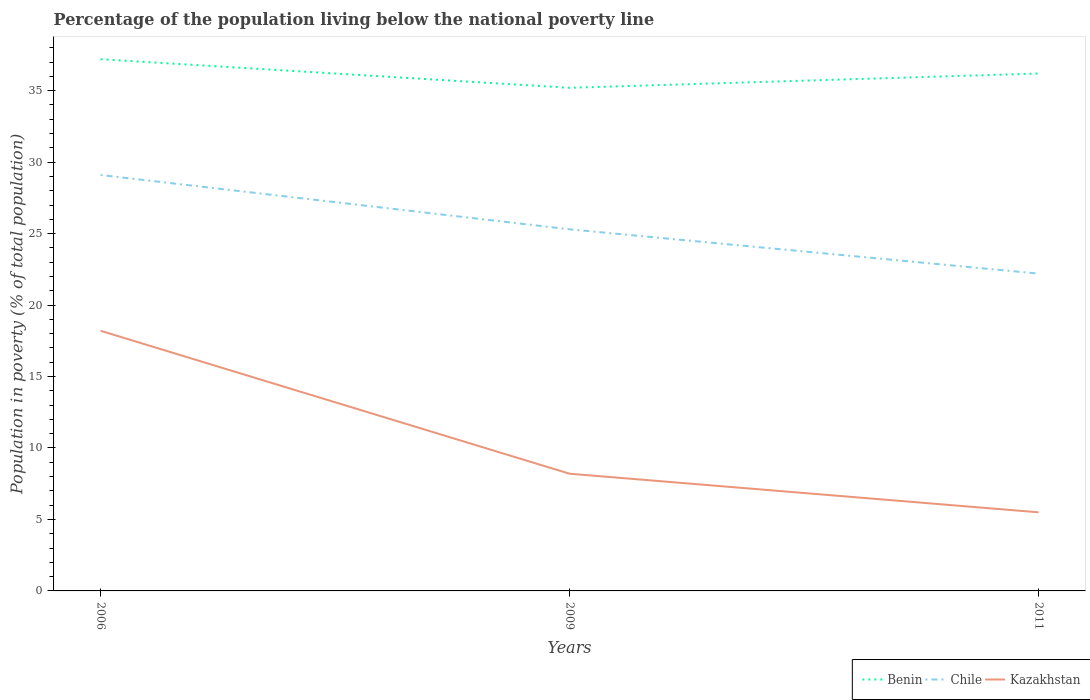Does the line corresponding to Kazakhstan intersect with the line corresponding to Benin?
Keep it short and to the point. No. Is the number of lines equal to the number of legend labels?
Your answer should be very brief. Yes. Across all years, what is the maximum percentage of the population living below the national poverty line in Kazakhstan?
Offer a very short reply. 5.5. What is the total percentage of the population living below the national poverty line in Benin in the graph?
Give a very brief answer. 2. What is the difference between the highest and the second highest percentage of the population living below the national poverty line in Chile?
Your answer should be compact. 6.9. What is the difference between the highest and the lowest percentage of the population living below the national poverty line in Chile?
Give a very brief answer. 1. How many lines are there?
Your response must be concise. 3. How many years are there in the graph?
Provide a succinct answer. 3. Are the values on the major ticks of Y-axis written in scientific E-notation?
Ensure brevity in your answer.  No. Does the graph contain any zero values?
Keep it short and to the point. No. Does the graph contain grids?
Make the answer very short. No. What is the title of the graph?
Your answer should be very brief. Percentage of the population living below the national poverty line. What is the label or title of the Y-axis?
Your answer should be very brief. Population in poverty (% of total population). What is the Population in poverty (% of total population) in Benin in 2006?
Ensure brevity in your answer.  37.2. What is the Population in poverty (% of total population) of Chile in 2006?
Provide a short and direct response. 29.1. What is the Population in poverty (% of total population) of Kazakhstan in 2006?
Keep it short and to the point. 18.2. What is the Population in poverty (% of total population) of Benin in 2009?
Provide a succinct answer. 35.2. What is the Population in poverty (% of total population) of Chile in 2009?
Offer a terse response. 25.3. What is the Population in poverty (% of total population) in Benin in 2011?
Keep it short and to the point. 36.2. Across all years, what is the maximum Population in poverty (% of total population) in Benin?
Your answer should be very brief. 37.2. Across all years, what is the maximum Population in poverty (% of total population) in Chile?
Your answer should be compact. 29.1. Across all years, what is the minimum Population in poverty (% of total population) of Benin?
Give a very brief answer. 35.2. What is the total Population in poverty (% of total population) of Benin in the graph?
Offer a terse response. 108.6. What is the total Population in poverty (% of total population) of Chile in the graph?
Your answer should be very brief. 76.6. What is the total Population in poverty (% of total population) in Kazakhstan in the graph?
Provide a short and direct response. 31.9. What is the difference between the Population in poverty (% of total population) of Kazakhstan in 2006 and that in 2009?
Keep it short and to the point. 10. What is the difference between the Population in poverty (% of total population) of Benin in 2006 and that in 2011?
Your response must be concise. 1. What is the difference between the Population in poverty (% of total population) in Chile in 2006 and that in 2011?
Your answer should be compact. 6.9. What is the difference between the Population in poverty (% of total population) in Benin in 2009 and that in 2011?
Ensure brevity in your answer.  -1. What is the difference between the Population in poverty (% of total population) in Chile in 2009 and that in 2011?
Offer a terse response. 3.1. What is the difference between the Population in poverty (% of total population) of Kazakhstan in 2009 and that in 2011?
Keep it short and to the point. 2.7. What is the difference between the Population in poverty (% of total population) in Benin in 2006 and the Population in poverty (% of total population) in Chile in 2009?
Provide a succinct answer. 11.9. What is the difference between the Population in poverty (% of total population) in Benin in 2006 and the Population in poverty (% of total population) in Kazakhstan in 2009?
Keep it short and to the point. 29. What is the difference between the Population in poverty (% of total population) in Chile in 2006 and the Population in poverty (% of total population) in Kazakhstan in 2009?
Your answer should be compact. 20.9. What is the difference between the Population in poverty (% of total population) in Benin in 2006 and the Population in poverty (% of total population) in Chile in 2011?
Ensure brevity in your answer.  15. What is the difference between the Population in poverty (% of total population) of Benin in 2006 and the Population in poverty (% of total population) of Kazakhstan in 2011?
Your response must be concise. 31.7. What is the difference between the Population in poverty (% of total population) of Chile in 2006 and the Population in poverty (% of total population) of Kazakhstan in 2011?
Your answer should be very brief. 23.6. What is the difference between the Population in poverty (% of total population) in Benin in 2009 and the Population in poverty (% of total population) in Chile in 2011?
Ensure brevity in your answer.  13. What is the difference between the Population in poverty (% of total population) of Benin in 2009 and the Population in poverty (% of total population) of Kazakhstan in 2011?
Your response must be concise. 29.7. What is the difference between the Population in poverty (% of total population) of Chile in 2009 and the Population in poverty (% of total population) of Kazakhstan in 2011?
Ensure brevity in your answer.  19.8. What is the average Population in poverty (% of total population) of Benin per year?
Ensure brevity in your answer.  36.2. What is the average Population in poverty (% of total population) in Chile per year?
Your answer should be compact. 25.53. What is the average Population in poverty (% of total population) of Kazakhstan per year?
Your response must be concise. 10.63. In the year 2006, what is the difference between the Population in poverty (% of total population) in Benin and Population in poverty (% of total population) in Kazakhstan?
Provide a succinct answer. 19. In the year 2009, what is the difference between the Population in poverty (% of total population) in Benin and Population in poverty (% of total population) in Chile?
Provide a short and direct response. 9.9. In the year 2009, what is the difference between the Population in poverty (% of total population) in Chile and Population in poverty (% of total population) in Kazakhstan?
Give a very brief answer. 17.1. In the year 2011, what is the difference between the Population in poverty (% of total population) in Benin and Population in poverty (% of total population) in Chile?
Offer a very short reply. 14. In the year 2011, what is the difference between the Population in poverty (% of total population) in Benin and Population in poverty (% of total population) in Kazakhstan?
Provide a succinct answer. 30.7. What is the ratio of the Population in poverty (% of total population) in Benin in 2006 to that in 2009?
Provide a succinct answer. 1.06. What is the ratio of the Population in poverty (% of total population) in Chile in 2006 to that in 2009?
Make the answer very short. 1.15. What is the ratio of the Population in poverty (% of total population) in Kazakhstan in 2006 to that in 2009?
Give a very brief answer. 2.22. What is the ratio of the Population in poverty (% of total population) in Benin in 2006 to that in 2011?
Keep it short and to the point. 1.03. What is the ratio of the Population in poverty (% of total population) of Chile in 2006 to that in 2011?
Your answer should be compact. 1.31. What is the ratio of the Population in poverty (% of total population) in Kazakhstan in 2006 to that in 2011?
Your response must be concise. 3.31. What is the ratio of the Population in poverty (% of total population) in Benin in 2009 to that in 2011?
Keep it short and to the point. 0.97. What is the ratio of the Population in poverty (% of total population) in Chile in 2009 to that in 2011?
Your response must be concise. 1.14. What is the ratio of the Population in poverty (% of total population) in Kazakhstan in 2009 to that in 2011?
Make the answer very short. 1.49. What is the difference between the highest and the second highest Population in poverty (% of total population) in Kazakhstan?
Offer a very short reply. 10. What is the difference between the highest and the lowest Population in poverty (% of total population) in Benin?
Offer a very short reply. 2. What is the difference between the highest and the lowest Population in poverty (% of total population) in Chile?
Your answer should be compact. 6.9. 